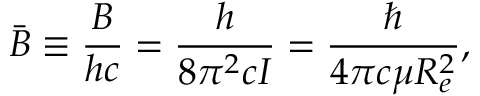<formula> <loc_0><loc_0><loc_500><loc_500>{ \bar { B } } \equiv \frac { B } { h c } = { \frac { h } { 8 \pi ^ { 2 } c I } } = { \frac { } { 4 \pi c \mu R _ { e } ^ { 2 } } } ,</formula> 